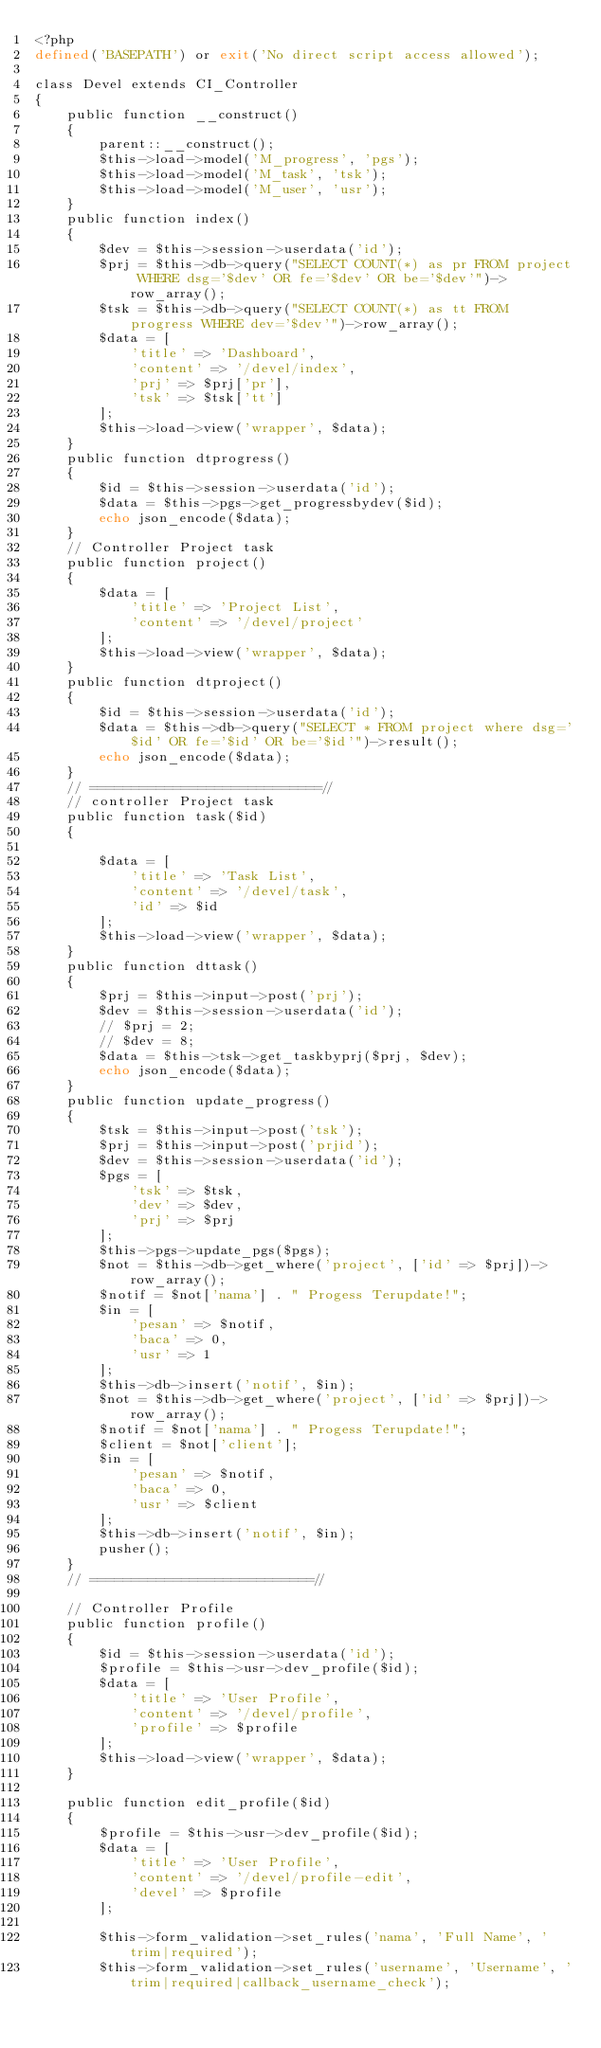Convert code to text. <code><loc_0><loc_0><loc_500><loc_500><_PHP_><?php
defined('BASEPATH') or exit('No direct script access allowed');

class Devel extends CI_Controller
{
    public function __construct()
    {
        parent::__construct();
        $this->load->model('M_progress', 'pgs');
        $this->load->model('M_task', 'tsk');
        $this->load->model('M_user', 'usr');
    }
    public function index()
    {
        $dev = $this->session->userdata('id');
        $prj = $this->db->query("SELECT COUNT(*) as pr FROM project WHERE dsg='$dev' OR fe='$dev' OR be='$dev'")->row_array();
        $tsk = $this->db->query("SELECT COUNT(*) as tt FROM progress WHERE dev='$dev'")->row_array();
        $data = [
            'title' => 'Dashboard',
            'content' => '/devel/index',
            'prj' => $prj['pr'],
            'tsk' => $tsk['tt']
        ];
        $this->load->view('wrapper', $data);
    }
    public function dtprogress()
    {
        $id = $this->session->userdata('id');
        $data = $this->pgs->get_progressbydev($id);
        echo json_encode($data);
    }
    // Controller Project task
    public function project()
    {
        $data = [
            'title' => 'Project List',
            'content' => '/devel/project'
        ];
        $this->load->view('wrapper', $data);
    }
    public function dtproject()
    {
        $id = $this->session->userdata('id');
        $data = $this->db->query("SELECT * FROM project where dsg='$id' OR fe='$id' OR be='$id'")->result();
        echo json_encode($data);
    }
    // ============================//
    // controller Project task
    public function task($id)
    {

        $data = [
            'title' => 'Task List',
            'content' => '/devel/task',
            'id' => $id
        ];
        $this->load->view('wrapper', $data);
    }
    public function dttask()
    {
        $prj = $this->input->post('prj');
        $dev = $this->session->userdata('id');
        // $prj = 2;
        // $dev = 8;
        $data = $this->tsk->get_taskbyprj($prj, $dev);
        echo json_encode($data);
    }
    public function update_progress()
    {
        $tsk = $this->input->post('tsk');
        $prj = $this->input->post('prjid');
        $dev = $this->session->userdata('id');
        $pgs = [
            'tsk' => $tsk,
            'dev' => $dev,
            'prj' => $prj
        ];
        $this->pgs->update_pgs($pgs);
        $not = $this->db->get_where('project', ['id' => $prj])->row_array();
        $notif = $not['nama'] . " Progess Terupdate!";
        $in = [
            'pesan' => $notif,
            'baca' => 0,
            'usr' => 1
        ];
        $this->db->insert('notif', $in);
        $not = $this->db->get_where('project', ['id' => $prj])->row_array();
        $notif = $not['nama'] . " Progess Terupdate!";
        $client = $not['client'];
        $in = [
            'pesan' => $notif,
            'baca' => 0,
            'usr' => $client
        ];
        $this->db->insert('notif', $in);
        pusher();
    }
    // ===========================//

    // Controller Profile
    public function profile()
    {
        $id = $this->session->userdata('id');
        $profile = $this->usr->dev_profile($id);
        $data = [
            'title' => 'User Profile',
            'content' => '/devel/profile',
            'profile' => $profile
        ];
        $this->load->view('wrapper', $data);
    }

    public function edit_profile($id)
    {
        $profile = $this->usr->dev_profile($id);
        $data = [
            'title' => 'User Profile',
            'content' => '/devel/profile-edit',
            'devel' => $profile
        ];

        $this->form_validation->set_rules('nama', 'Full Name', 'trim|required');
        $this->form_validation->set_rules('username', 'Username', 'trim|required|callback_username_check');</code> 